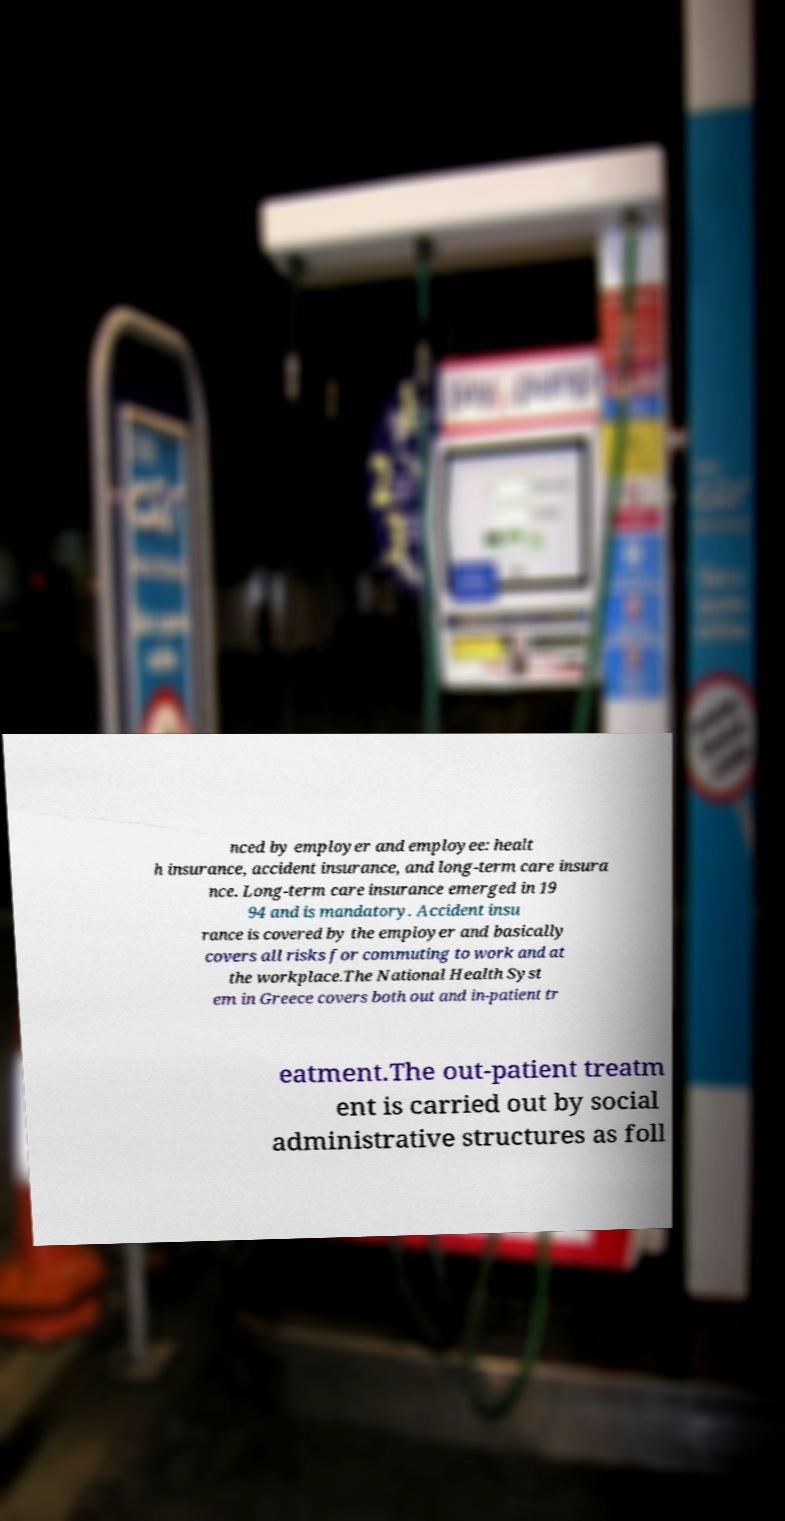Can you read and provide the text displayed in the image?This photo seems to have some interesting text. Can you extract and type it out for me? nced by employer and employee: healt h insurance, accident insurance, and long-term care insura nce. Long-term care insurance emerged in 19 94 and is mandatory. Accident insu rance is covered by the employer and basically covers all risks for commuting to work and at the workplace.The National Health Syst em in Greece covers both out and in-patient tr eatment.The out-patient treatm ent is carried out by social administrative structures as foll 